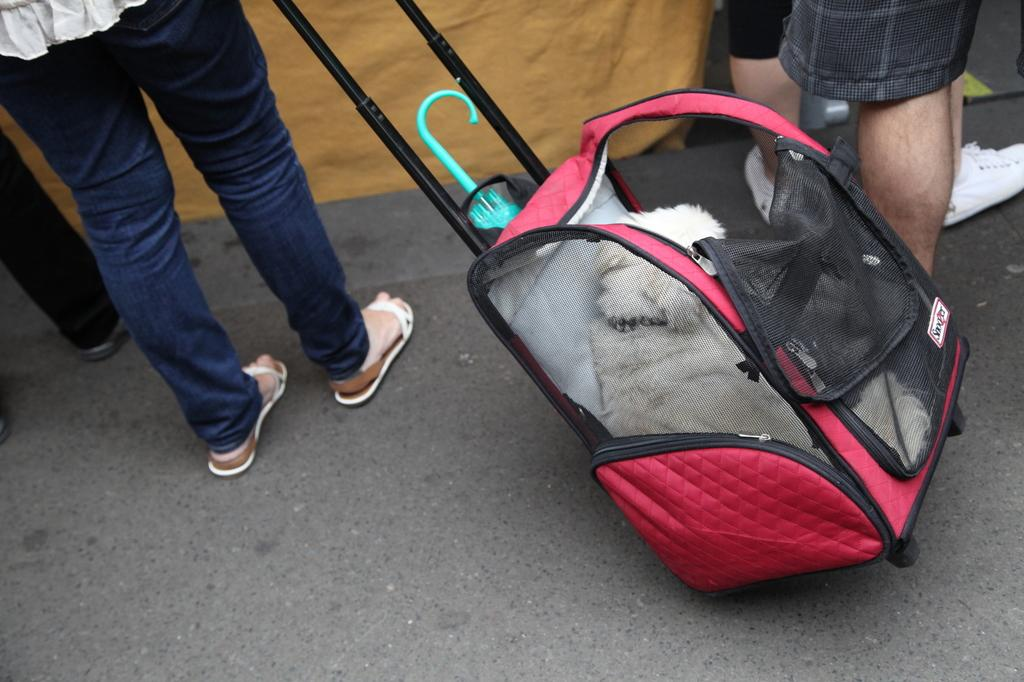What are the people in the image doing? The people in the image are standing. What is one of the people holding? One of the people is holding a luggage. What is inside the luggage? There is a dog in the luggage. What object can be seen in the image related to weather protection? There is an umbrella in the image. Where is the umbrella located? The umbrella is on the road. What type of lunch is being served in the image? There is no lunch being served in the image; it features people standing, luggage, a dog, and an umbrella. 